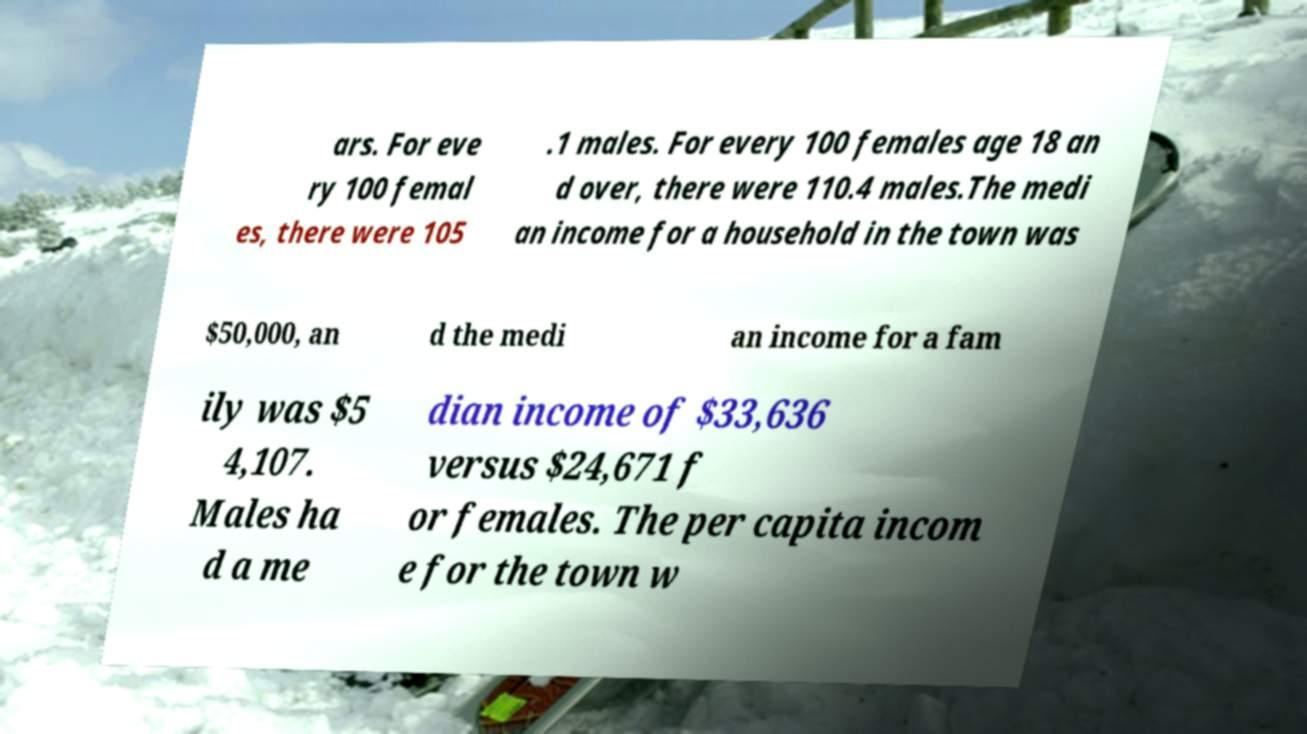Could you assist in decoding the text presented in this image and type it out clearly? ars. For eve ry 100 femal es, there were 105 .1 males. For every 100 females age 18 an d over, there were 110.4 males.The medi an income for a household in the town was $50,000, an d the medi an income for a fam ily was $5 4,107. Males ha d a me dian income of $33,636 versus $24,671 f or females. The per capita incom e for the town w 